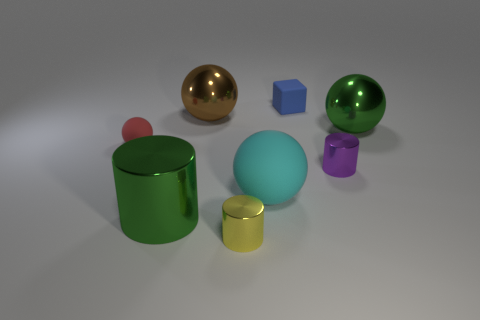Add 1 green metal things. How many objects exist? 9 Subtract all cubes. How many objects are left? 7 Subtract 0 cyan cylinders. How many objects are left? 8 Subtract all green metal things. Subtract all green cylinders. How many objects are left? 5 Add 6 big rubber objects. How many big rubber objects are left? 7 Add 1 brown balls. How many brown balls exist? 2 